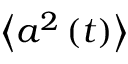<formula> <loc_0><loc_0><loc_500><loc_500>\left \langle a ^ { 2 } \left ( t \right ) \right \rangle</formula> 